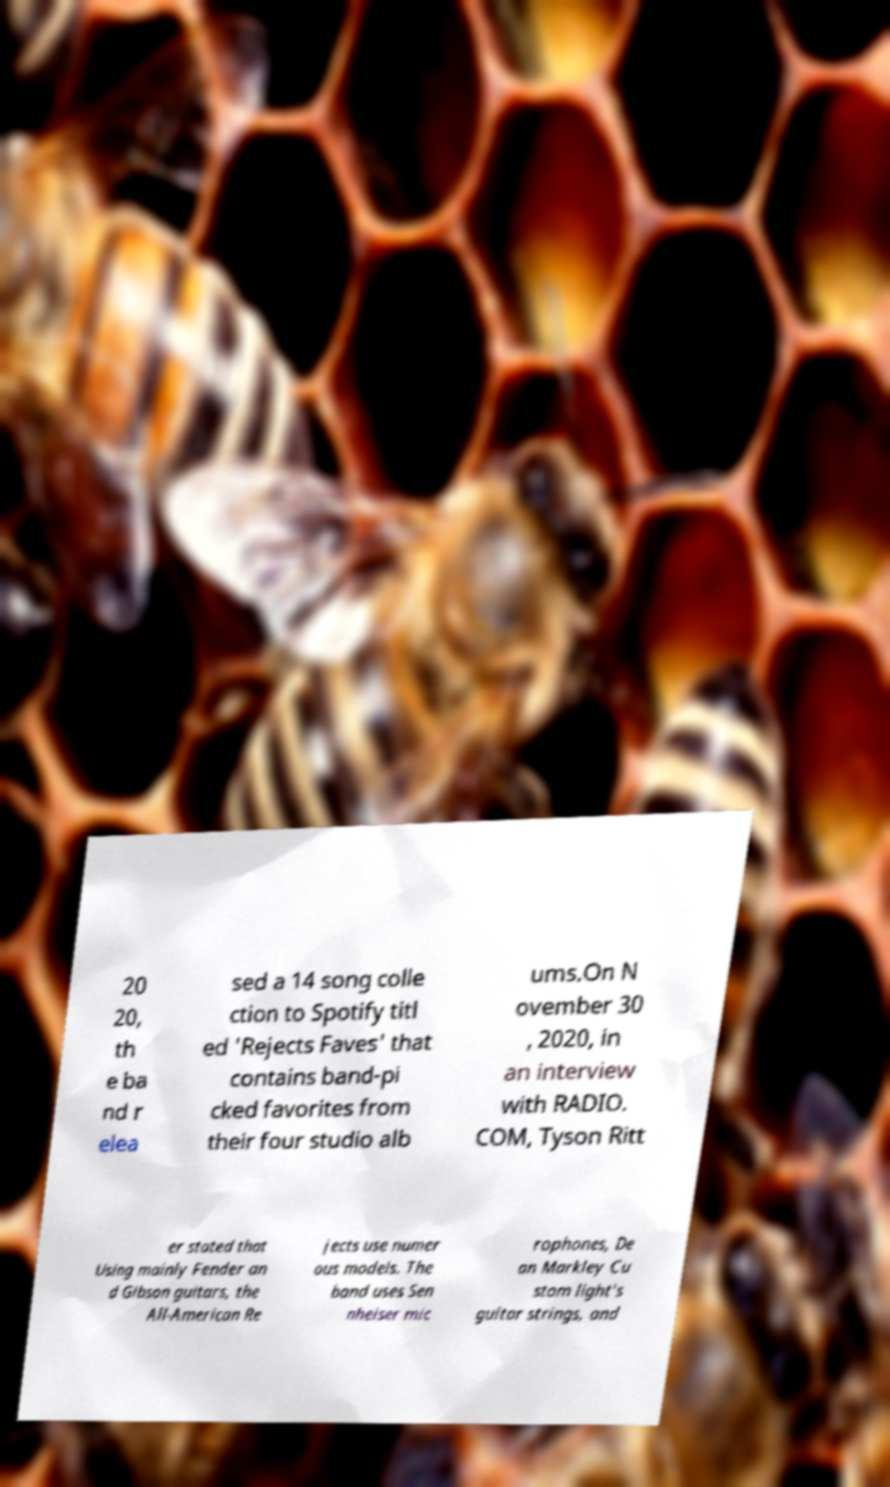Could you assist in decoding the text presented in this image and type it out clearly? 20 20, th e ba nd r elea sed a 14 song colle ction to Spotify titl ed 'Rejects Faves' that contains band-pi cked favorites from their four studio alb ums.On N ovember 30 , 2020, in an interview with RADIO. COM, Tyson Ritt er stated that Using mainly Fender an d Gibson guitars, the All-American Re jects use numer ous models. The band uses Sen nheiser mic rophones, De an Markley Cu stom light's guitar strings, and 